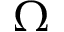Convert formula to latex. <formula><loc_0><loc_0><loc_500><loc_500>\Omega</formula> 